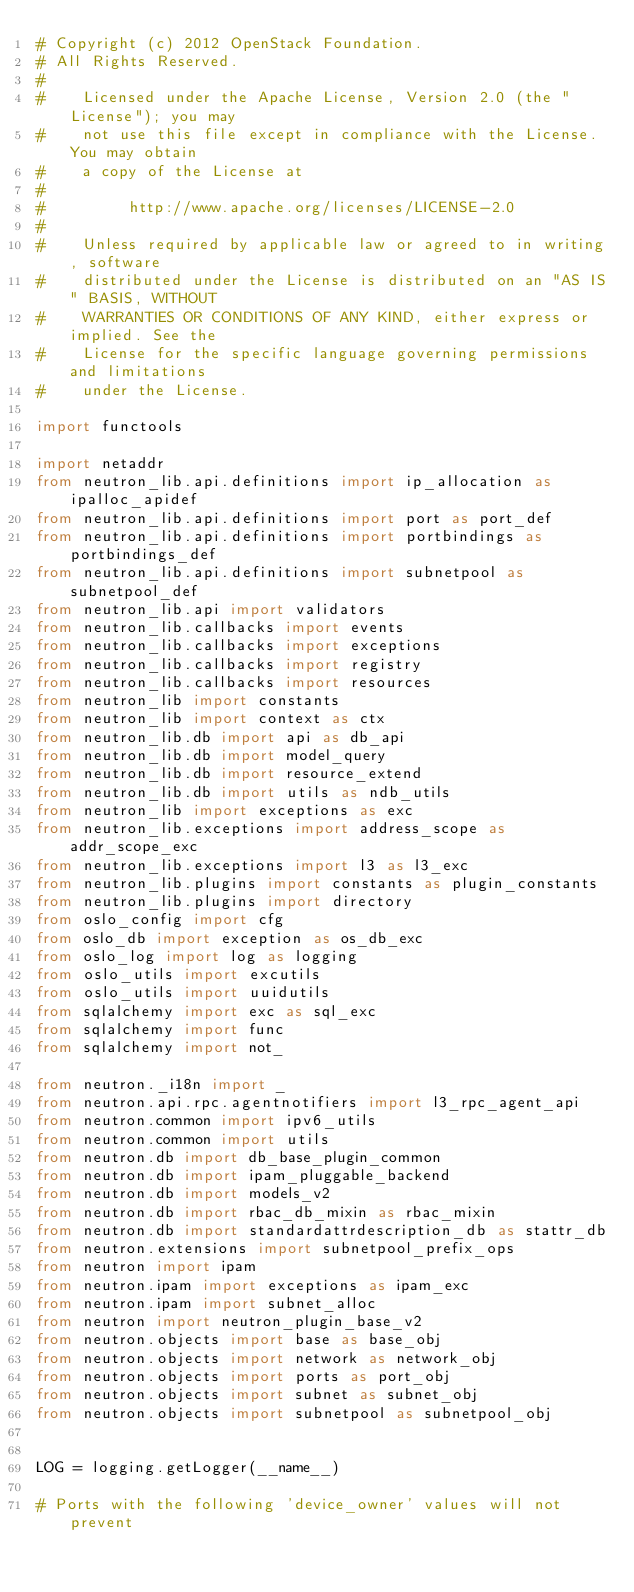Convert code to text. <code><loc_0><loc_0><loc_500><loc_500><_Python_># Copyright (c) 2012 OpenStack Foundation.
# All Rights Reserved.
#
#    Licensed under the Apache License, Version 2.0 (the "License"); you may
#    not use this file except in compliance with the License. You may obtain
#    a copy of the License at
#
#         http://www.apache.org/licenses/LICENSE-2.0
#
#    Unless required by applicable law or agreed to in writing, software
#    distributed under the License is distributed on an "AS IS" BASIS, WITHOUT
#    WARRANTIES OR CONDITIONS OF ANY KIND, either express or implied. See the
#    License for the specific language governing permissions and limitations
#    under the License.

import functools

import netaddr
from neutron_lib.api.definitions import ip_allocation as ipalloc_apidef
from neutron_lib.api.definitions import port as port_def
from neutron_lib.api.definitions import portbindings as portbindings_def
from neutron_lib.api.definitions import subnetpool as subnetpool_def
from neutron_lib.api import validators
from neutron_lib.callbacks import events
from neutron_lib.callbacks import exceptions
from neutron_lib.callbacks import registry
from neutron_lib.callbacks import resources
from neutron_lib import constants
from neutron_lib import context as ctx
from neutron_lib.db import api as db_api
from neutron_lib.db import model_query
from neutron_lib.db import resource_extend
from neutron_lib.db import utils as ndb_utils
from neutron_lib import exceptions as exc
from neutron_lib.exceptions import address_scope as addr_scope_exc
from neutron_lib.exceptions import l3 as l3_exc
from neutron_lib.plugins import constants as plugin_constants
from neutron_lib.plugins import directory
from oslo_config import cfg
from oslo_db import exception as os_db_exc
from oslo_log import log as logging
from oslo_utils import excutils
from oslo_utils import uuidutils
from sqlalchemy import exc as sql_exc
from sqlalchemy import func
from sqlalchemy import not_

from neutron._i18n import _
from neutron.api.rpc.agentnotifiers import l3_rpc_agent_api
from neutron.common import ipv6_utils
from neutron.common import utils
from neutron.db import db_base_plugin_common
from neutron.db import ipam_pluggable_backend
from neutron.db import models_v2
from neutron.db import rbac_db_mixin as rbac_mixin
from neutron.db import standardattrdescription_db as stattr_db
from neutron.extensions import subnetpool_prefix_ops
from neutron import ipam
from neutron.ipam import exceptions as ipam_exc
from neutron.ipam import subnet_alloc
from neutron import neutron_plugin_base_v2
from neutron.objects import base as base_obj
from neutron.objects import network as network_obj
from neutron.objects import ports as port_obj
from neutron.objects import subnet as subnet_obj
from neutron.objects import subnetpool as subnetpool_obj


LOG = logging.getLogger(__name__)

# Ports with the following 'device_owner' values will not prevent</code> 